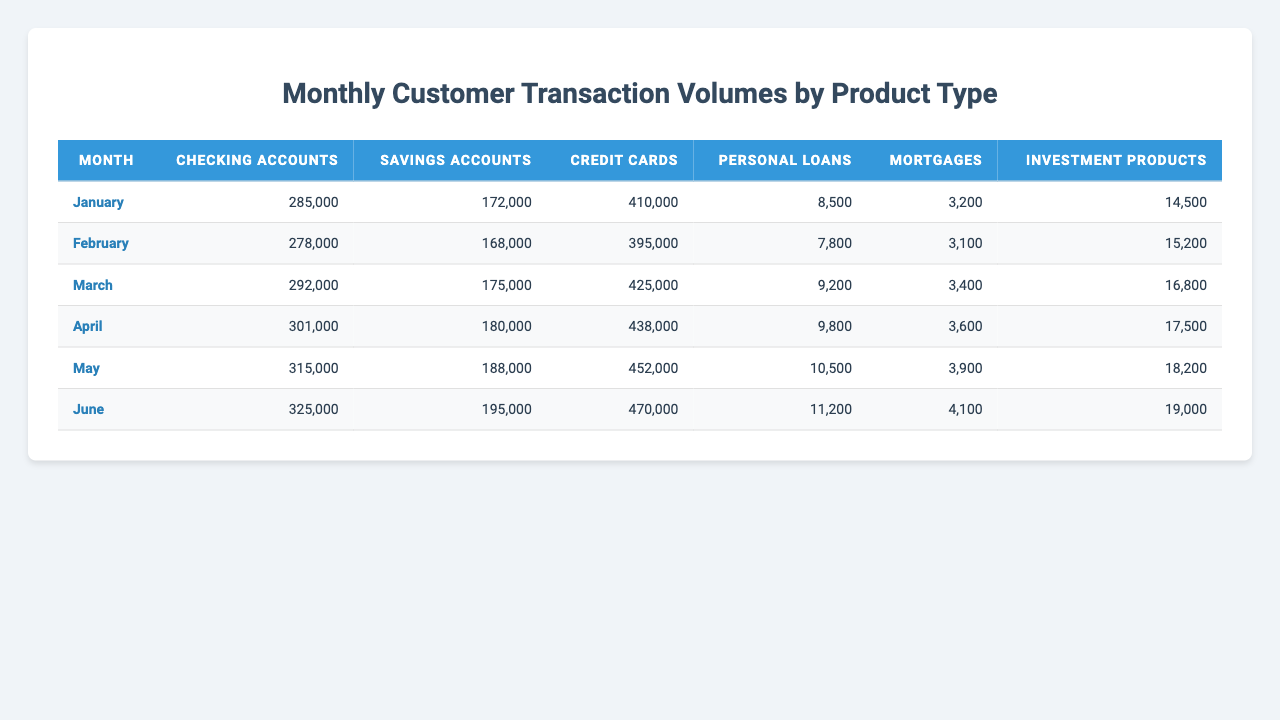What was the total transaction volume for credit cards in March? In the month of March, the credit card transaction volume is 425,000.
Answer: 425000 Which product type had the highest transaction volume in April? In April, the highest transaction volume is for credit cards with 438,000.
Answer: Credit cards What is the difference in the transaction volume of checking accounts between May and February? In May, the transaction volume for checking accounts is 315,000, and in February, it is 278,000. The difference is 315,000 - 278,000 = 37,000.
Answer: 37000 What was the average transaction volume for personal loans from January to June? Summing the transaction volumes for personal loans: 8,500 + 7,800 + 9,200 + 9,800 + 10,500 + 11,200 gives 57,000. There are 6 months, so the average is 57,000 / 6 = 9,500.
Answer: 9500 Did the transaction volume for mortgages increase from January to June? In January, the volume was 3,200, and in June, it was 4,100. Since 4,100 is greater than 3,200, the volume increased.
Answer: Yes Which product saw the greatest increase in transaction volume from January to June? Looking at the data, credit cards increased from 410,000 in January to 470,000 in June, which is an increase of 60,000. Savings accounts increased from 172,000 to 195,000, which is 23,000. The maximum increase was in credit cards.
Answer: Credit cards What was the total transaction volume for all product types in June? The transaction volumes in June are: Checking accounts 325,000, Savings accounts 195,000, Credit cards 470,000, Personal loans 11,200, Mortgages 4,100, Investment products 19,000. Summing these gives 325,000 + 195,000 + 470,000 + 11,200 + 4,100 + 19,000 = 1,024,300.
Answer: 1024300 In which month did savings accounts have the lowest transaction volume? Checking the savings account volumes, January had 172,000, February had 168,000, March had 175,000, April had 180,000, May had 188,000, and June had 195,000. February had the lowest at 168,000.
Answer: February What percentage of the total transactions in June were from credit cards? The total transactions in June were 1,024,300 (as calculated previously), and credit card transactions were 470,000. The percentage is (470,000 / 1,024,300) * 100 = approximately 45.9%.
Answer: 45.9% What is the total number of transactions for both checking accounts and personal loans in May? In May, checking accounts had 315,000 transactions and personal loans had 10,500. The total is 315,000 + 10,500 = 325,500.
Answer: 325500 